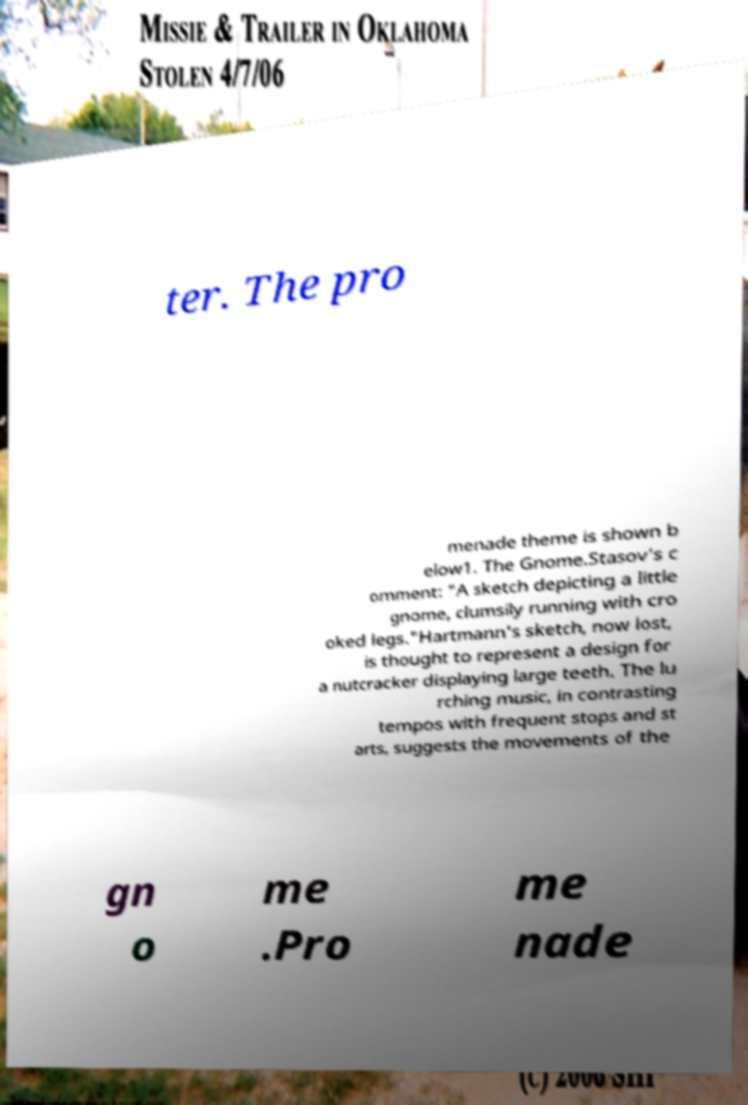For documentation purposes, I need the text within this image transcribed. Could you provide that? ter. The pro menade theme is shown b elow1. The Gnome.Stasov's c omment: "A sketch depicting a little gnome, clumsily running with cro oked legs."Hartmann's sketch, now lost, is thought to represent a design for a nutcracker displaying large teeth. The lu rching music, in contrasting tempos with frequent stops and st arts, suggests the movements of the gn o me .Pro me nade 